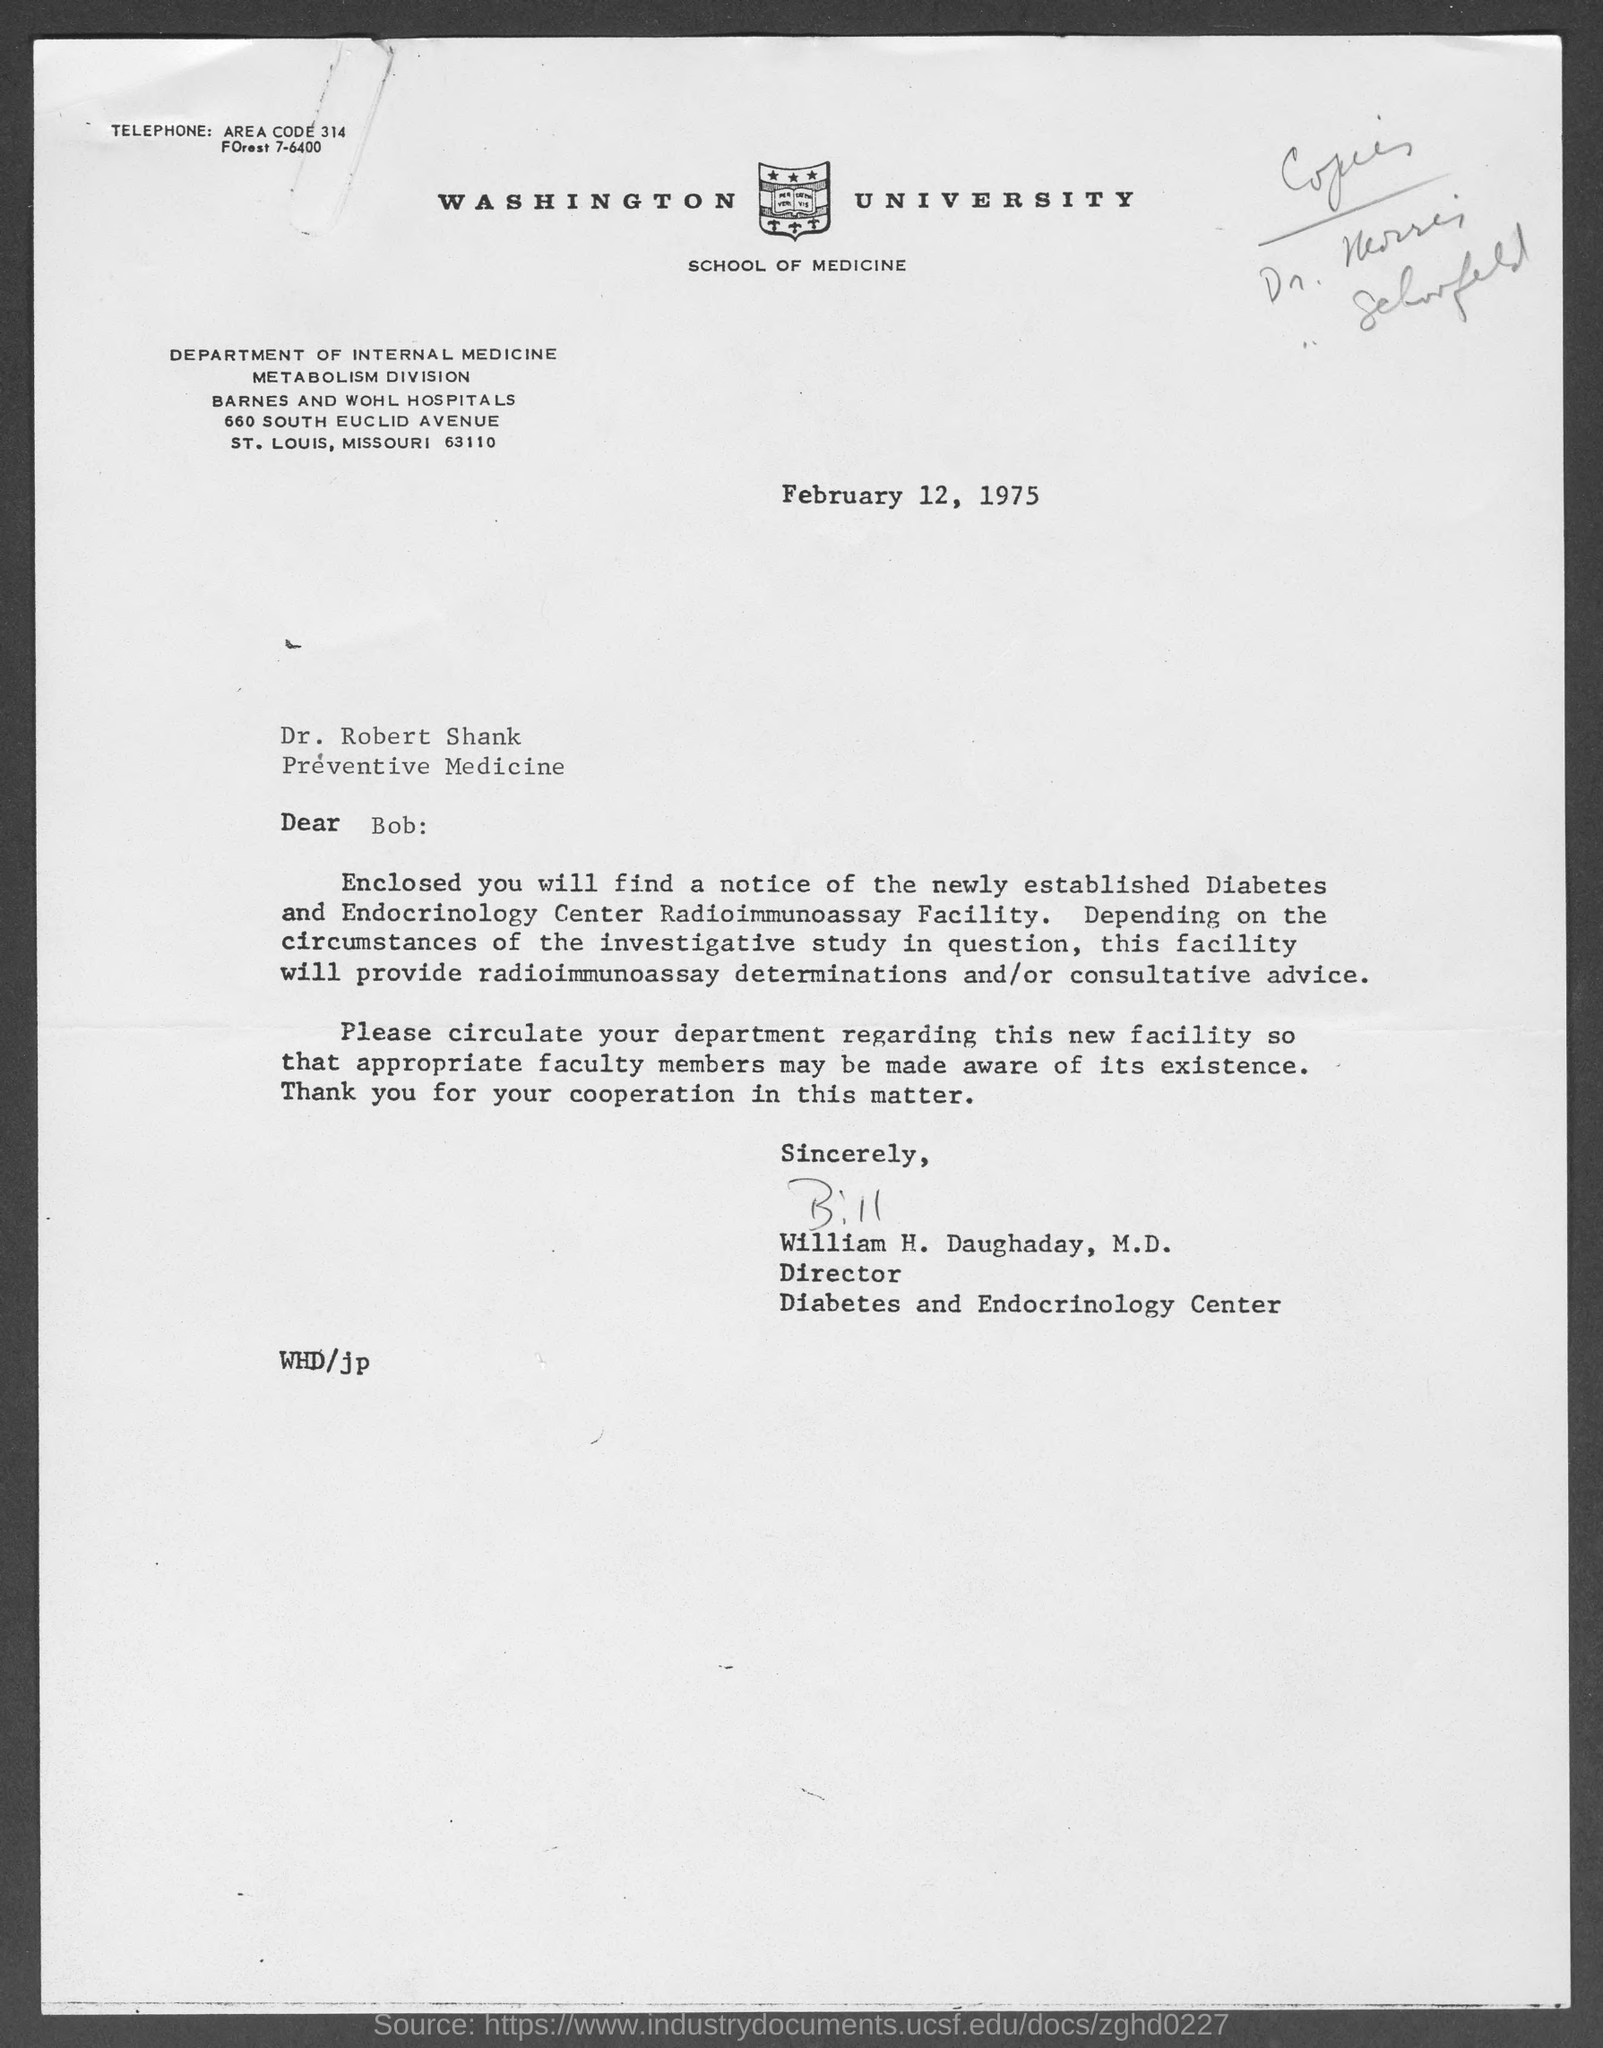Outline some significant characteristics in this image. The letter is addressed to Dr. Robert Shank. The letter is from William H. Daughaday. The date on the document is February 12, 1975. 